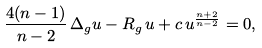<formula> <loc_0><loc_0><loc_500><loc_500>\frac { 4 ( n - 1 ) } { n - 2 } \, \Delta _ { g } u - R _ { g } \, u + c \, u ^ { \frac { n + 2 } { n - 2 } } = 0 ,</formula> 